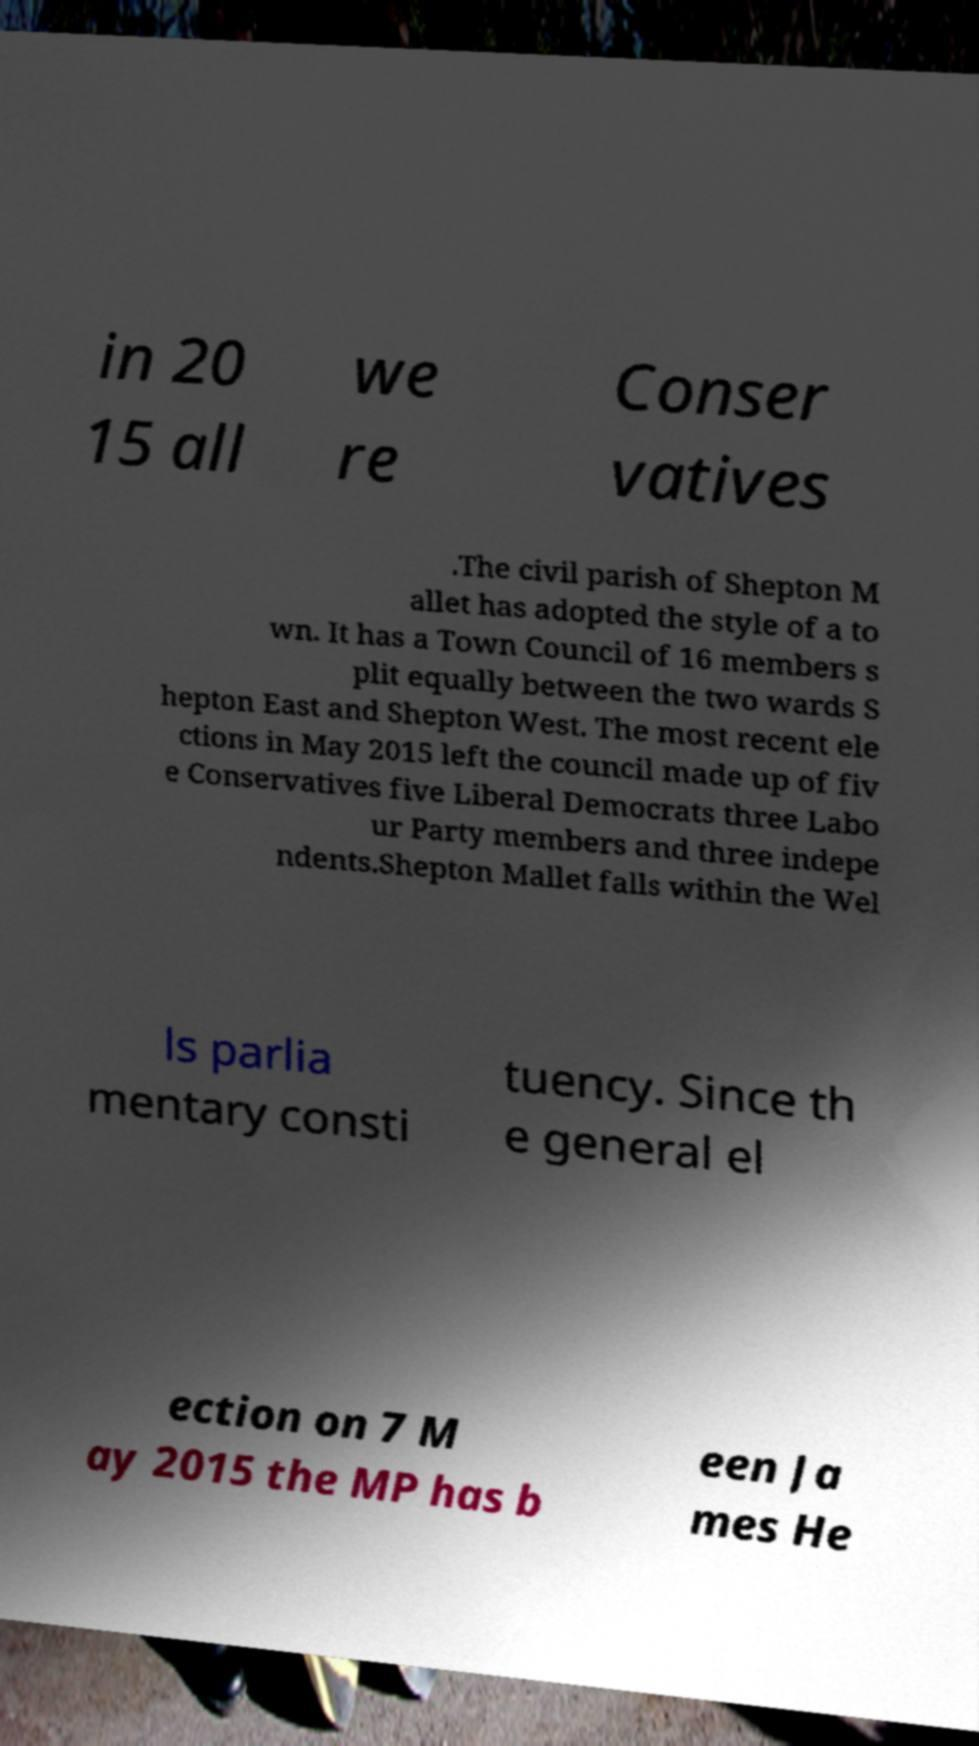I need the written content from this picture converted into text. Can you do that? in 20 15 all we re Conser vatives .The civil parish of Shepton M allet has adopted the style of a to wn. It has a Town Council of 16 members s plit equally between the two wards S hepton East and Shepton West. The most recent ele ctions in May 2015 left the council made up of fiv e Conservatives five Liberal Democrats three Labo ur Party members and three indepe ndents.Shepton Mallet falls within the Wel ls parlia mentary consti tuency. Since th e general el ection on 7 M ay 2015 the MP has b een Ja mes He 